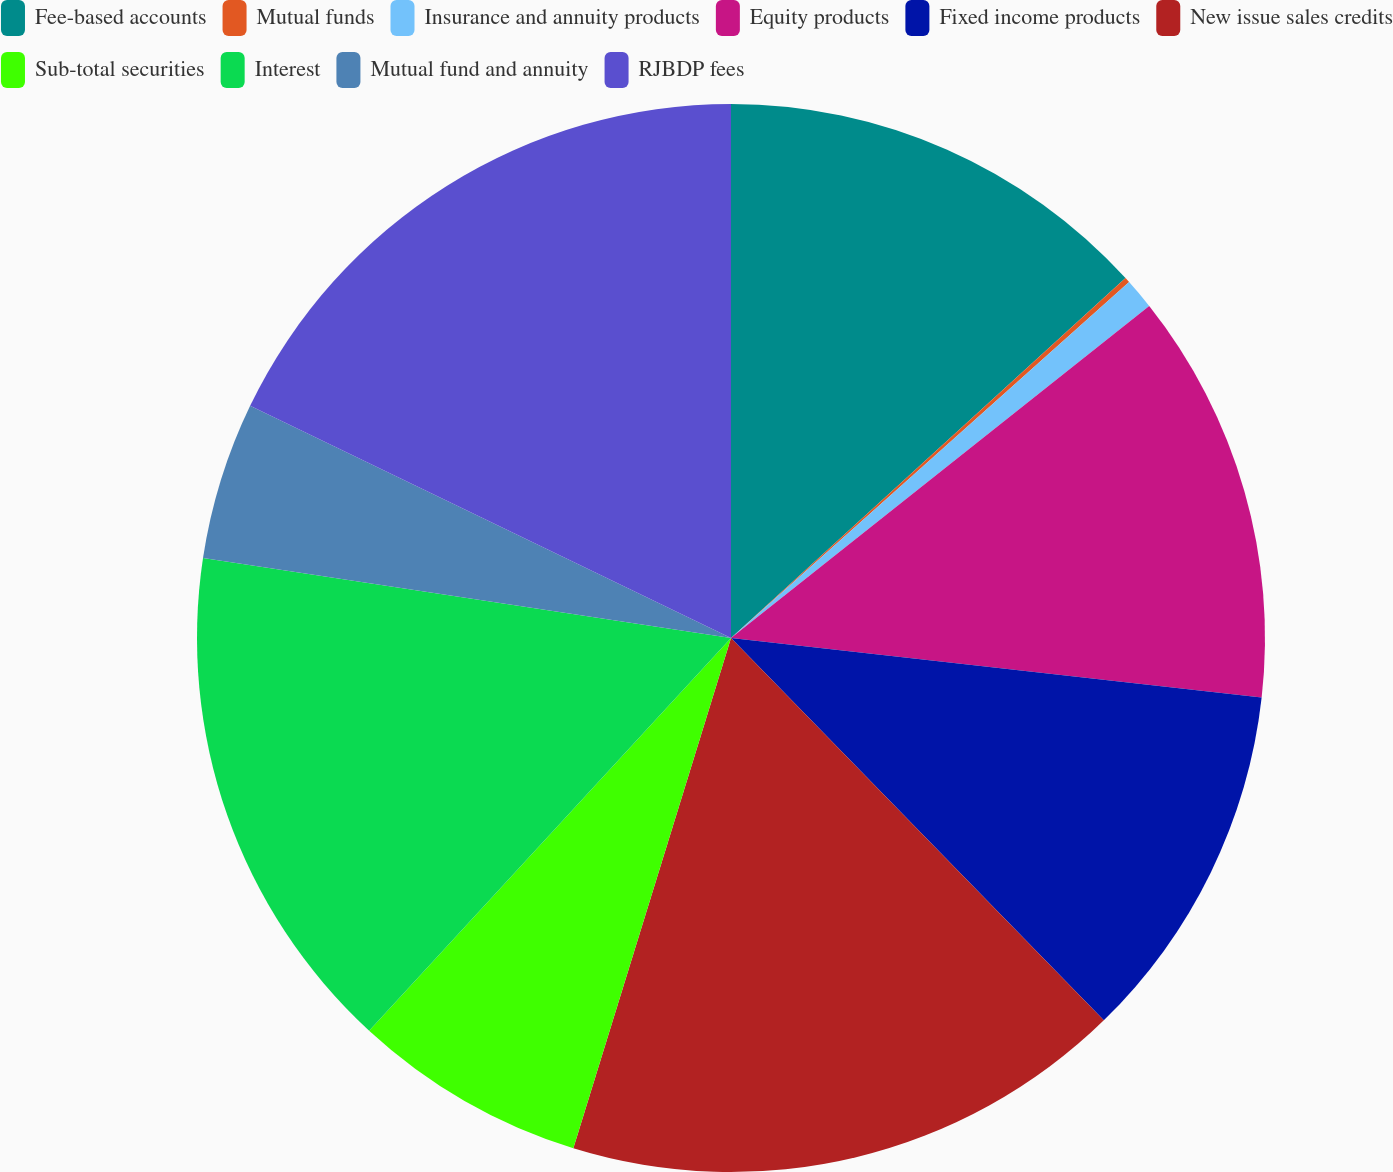Convert chart. <chart><loc_0><loc_0><loc_500><loc_500><pie_chart><fcel>Fee-based accounts<fcel>Mutual funds<fcel>Insurance and annuity products<fcel>Equity products<fcel>Fixed income products<fcel>New issue sales credits<fcel>Sub-total securities<fcel>Interest<fcel>Mutual fund and annuity<fcel>RJBDP fees<nl><fcel>13.23%<fcel>0.16%<fcel>0.93%<fcel>12.46%<fcel>10.92%<fcel>17.07%<fcel>7.08%<fcel>15.54%<fcel>4.77%<fcel>17.84%<nl></chart> 